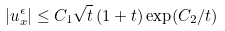<formula> <loc_0><loc_0><loc_500><loc_500>| u ^ { \epsilon } _ { x } | \leq C _ { 1 } \sqrt { t } \left ( 1 + t \right ) \exp ( C _ { 2 } / t )</formula> 